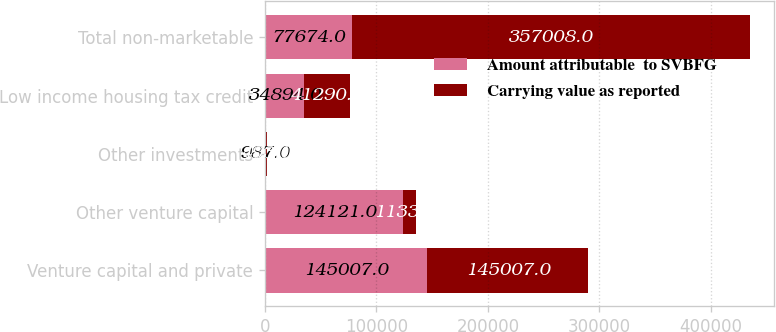<chart> <loc_0><loc_0><loc_500><loc_500><stacked_bar_chart><ecel><fcel>Venture capital and private<fcel>Other venture capital<fcel>Other investments<fcel>Low income housing tax credit<fcel>Total non-marketable<nl><fcel>Amount attributable  to SVBFG<fcel>145007<fcel>124121<fcel>987<fcel>34894<fcel>77674<nl><fcel>Carrying value as reported<fcel>145007<fcel>11333<fcel>493<fcel>41290<fcel>357008<nl></chart> 